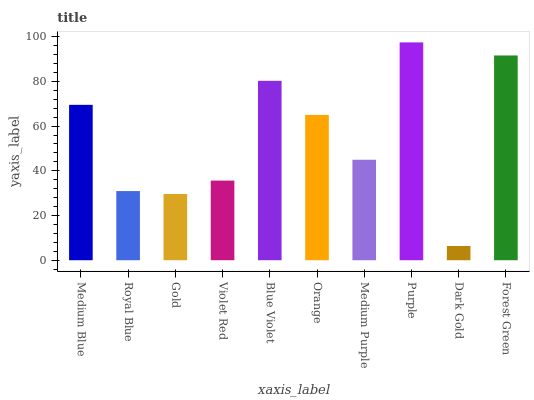Is Royal Blue the minimum?
Answer yes or no. No. Is Royal Blue the maximum?
Answer yes or no. No. Is Medium Blue greater than Royal Blue?
Answer yes or no. Yes. Is Royal Blue less than Medium Blue?
Answer yes or no. Yes. Is Royal Blue greater than Medium Blue?
Answer yes or no. No. Is Medium Blue less than Royal Blue?
Answer yes or no. No. Is Orange the high median?
Answer yes or no. Yes. Is Medium Purple the low median?
Answer yes or no. Yes. Is Gold the high median?
Answer yes or no. No. Is Royal Blue the low median?
Answer yes or no. No. 